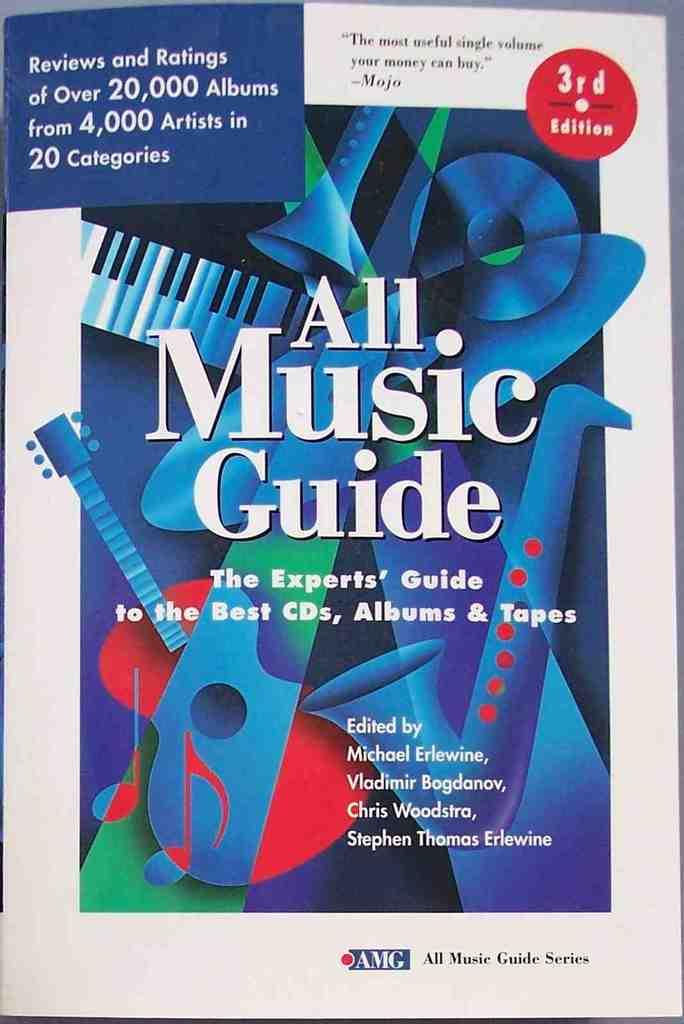What is the main subject of the picture? The main subject of the picture is an image of a book. What can be read on the book in the picture? The book has the words "All music guide" written on it. Reasoning: Let' Let's think step by step in order to produce the conversation. We start by identifying the main subject of the image, which is the book. Then, we describe the specific details of the book, such as the words written on it. Each question is designed to elicit a specific detail about the image that is known from the provided facts. Absurd Question/Answer: What type of shoes can be seen in the image? There are no shoes present in the image; it features an image of a book with the words "All music guide" written on it. What fact about the wind can be observed in the image? There is no information about the wind in the image, as it only features an image of a book with the words "All music guide" written on it. What type of shoes can be seen in the image? There are no shoes present in the image; it features an image of a book with the words "All music guide" written on it. What fact about the wind can be observed in the image? There is no information about the wind in the image, as it only features an image of a book with the words "All music guide" written on it. 